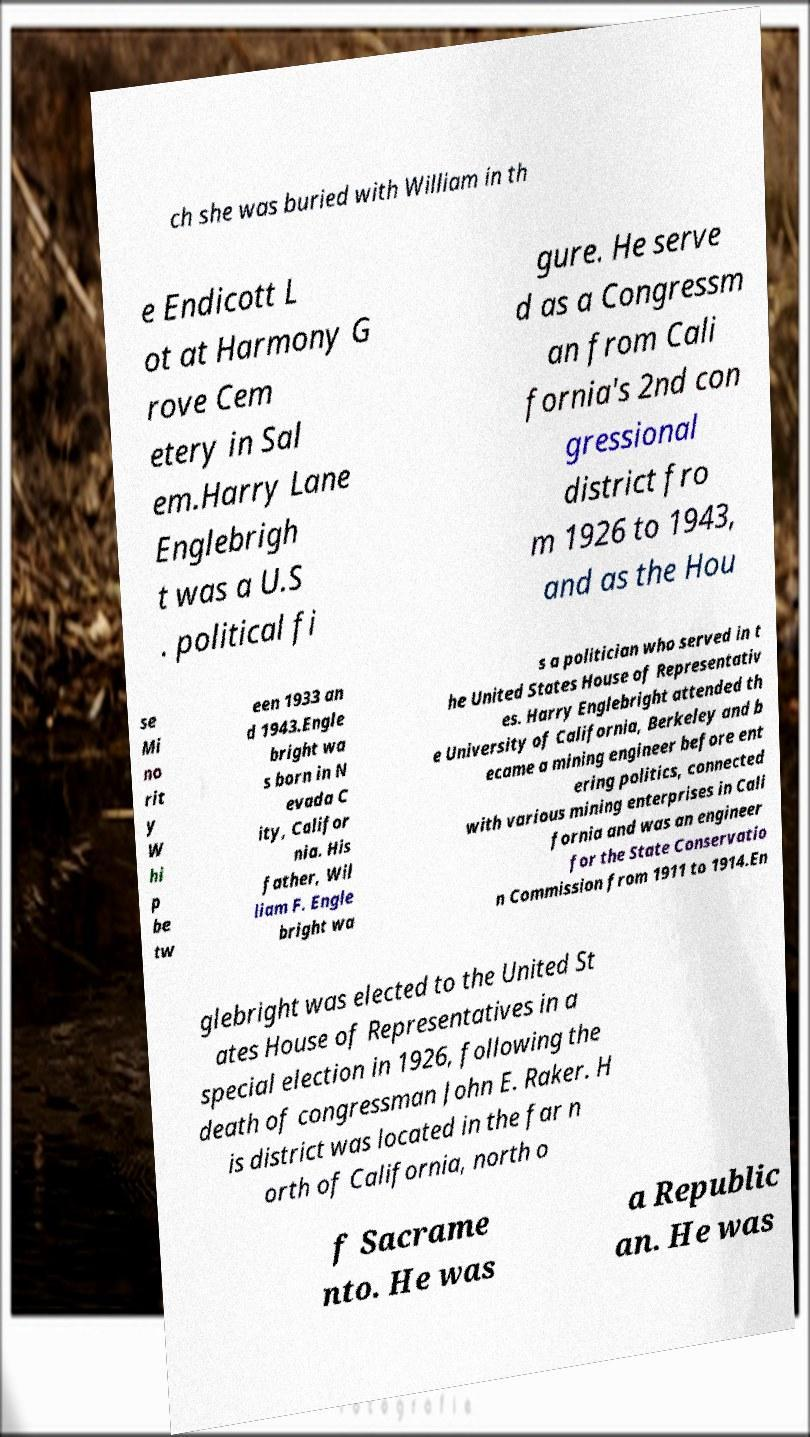Can you accurately transcribe the text from the provided image for me? ch she was buried with William in th e Endicott L ot at Harmony G rove Cem etery in Sal em.Harry Lane Englebrigh t was a U.S . political fi gure. He serve d as a Congressm an from Cali fornia's 2nd con gressional district fro m 1926 to 1943, and as the Hou se Mi no rit y W hi p be tw een 1933 an d 1943.Engle bright wa s born in N evada C ity, Califor nia. His father, Wil liam F. Engle bright wa s a politician who served in t he United States House of Representativ es. Harry Englebright attended th e University of California, Berkeley and b ecame a mining engineer before ent ering politics, connected with various mining enterprises in Cali fornia and was an engineer for the State Conservatio n Commission from 1911 to 1914.En glebright was elected to the United St ates House of Representatives in a special election in 1926, following the death of congressman John E. Raker. H is district was located in the far n orth of California, north o f Sacrame nto. He was a Republic an. He was 